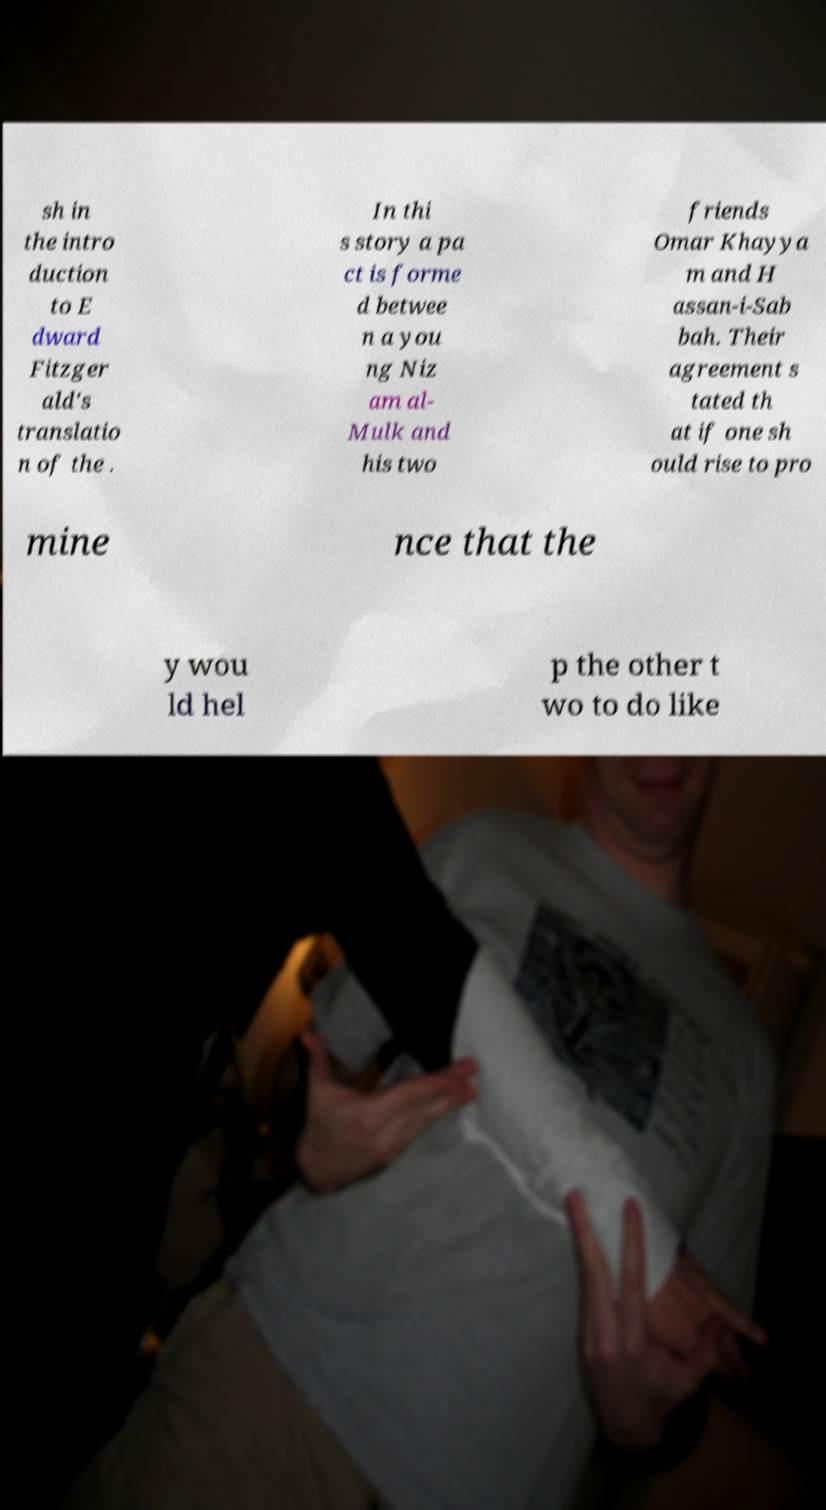For documentation purposes, I need the text within this image transcribed. Could you provide that? sh in the intro duction to E dward Fitzger ald's translatio n of the . In thi s story a pa ct is forme d betwee n a you ng Niz am al- Mulk and his two friends Omar Khayya m and H assan-i-Sab bah. Their agreement s tated th at if one sh ould rise to pro mine nce that the y wou ld hel p the other t wo to do like 